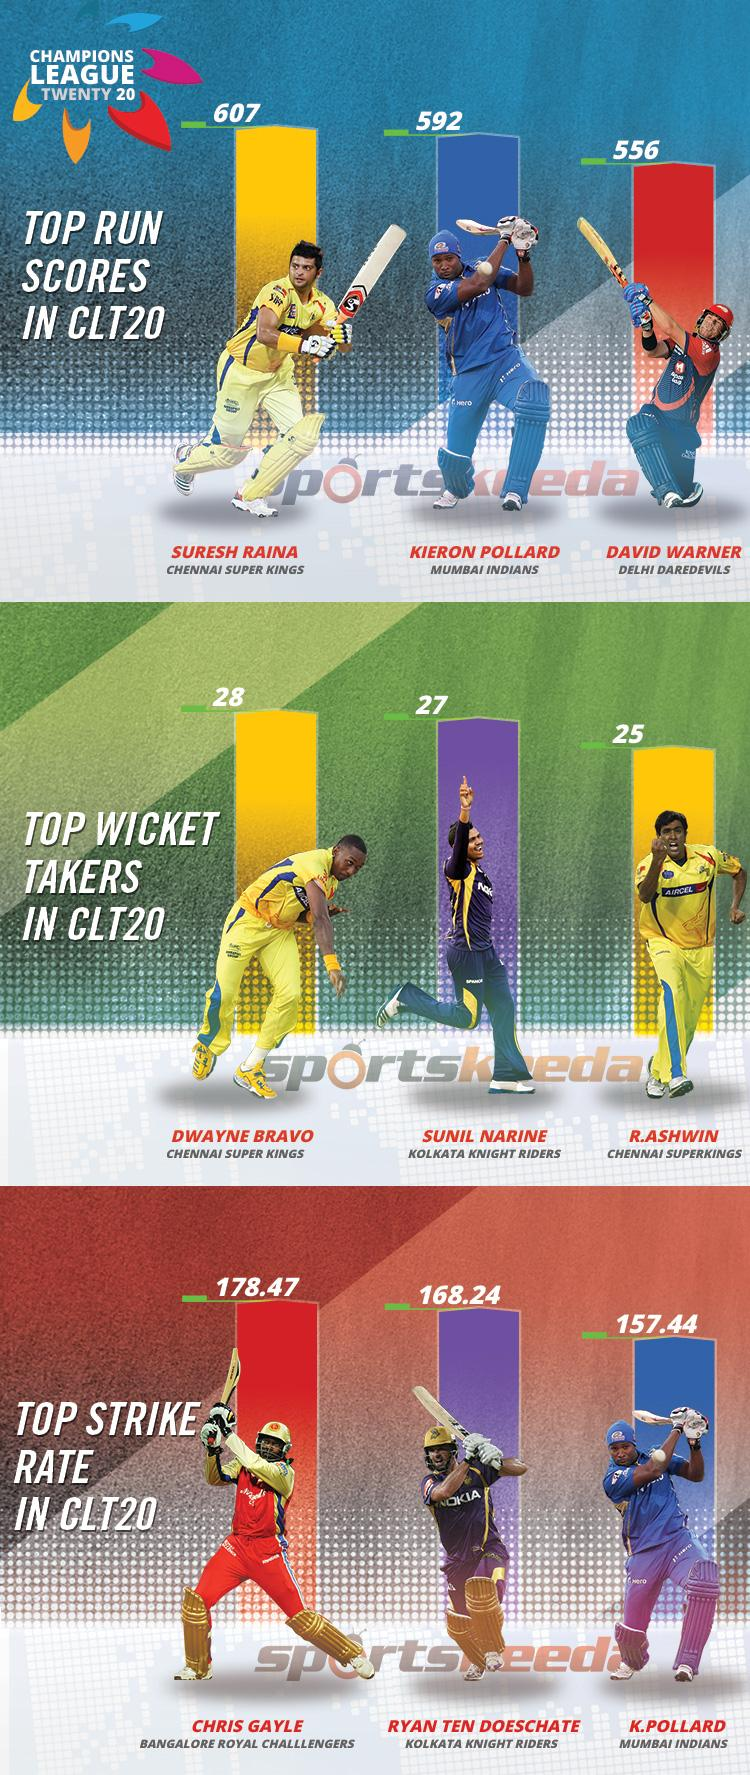Identify some key points in this picture. David Warner plays for the Delhi Daredevils in the Champions League Twenty20 tournament. With a strike rate of 93.33%, Chris Gayle reigns as the top player in the CLT20! Sunil Narine is the second highest wicket taker in CLT20 matches. Kumar Sangakkara has a strike rate of 157.44 in the Champions League Twenty20. Chris Gayle, who plays for the Bangalore Royal Challengers in the CLT20, is a talented batsman known for his powerful hitting and dominating performances on the cricket field. 